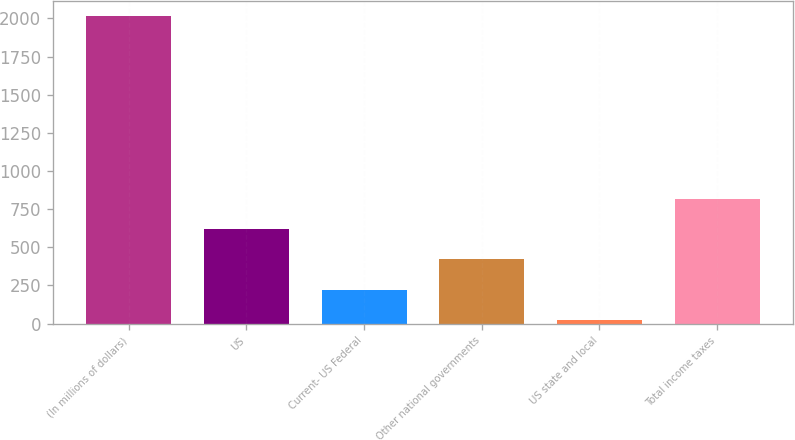<chart> <loc_0><loc_0><loc_500><loc_500><bar_chart><fcel>(In millions of dollars)<fcel>US<fcel>Current- US Federal<fcel>Other national governments<fcel>US state and local<fcel>Total income taxes<nl><fcel>2013<fcel>619.3<fcel>221.1<fcel>420.2<fcel>22<fcel>818.4<nl></chart> 